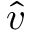Convert formula to latex. <formula><loc_0><loc_0><loc_500><loc_500>\hat { v }</formula> 